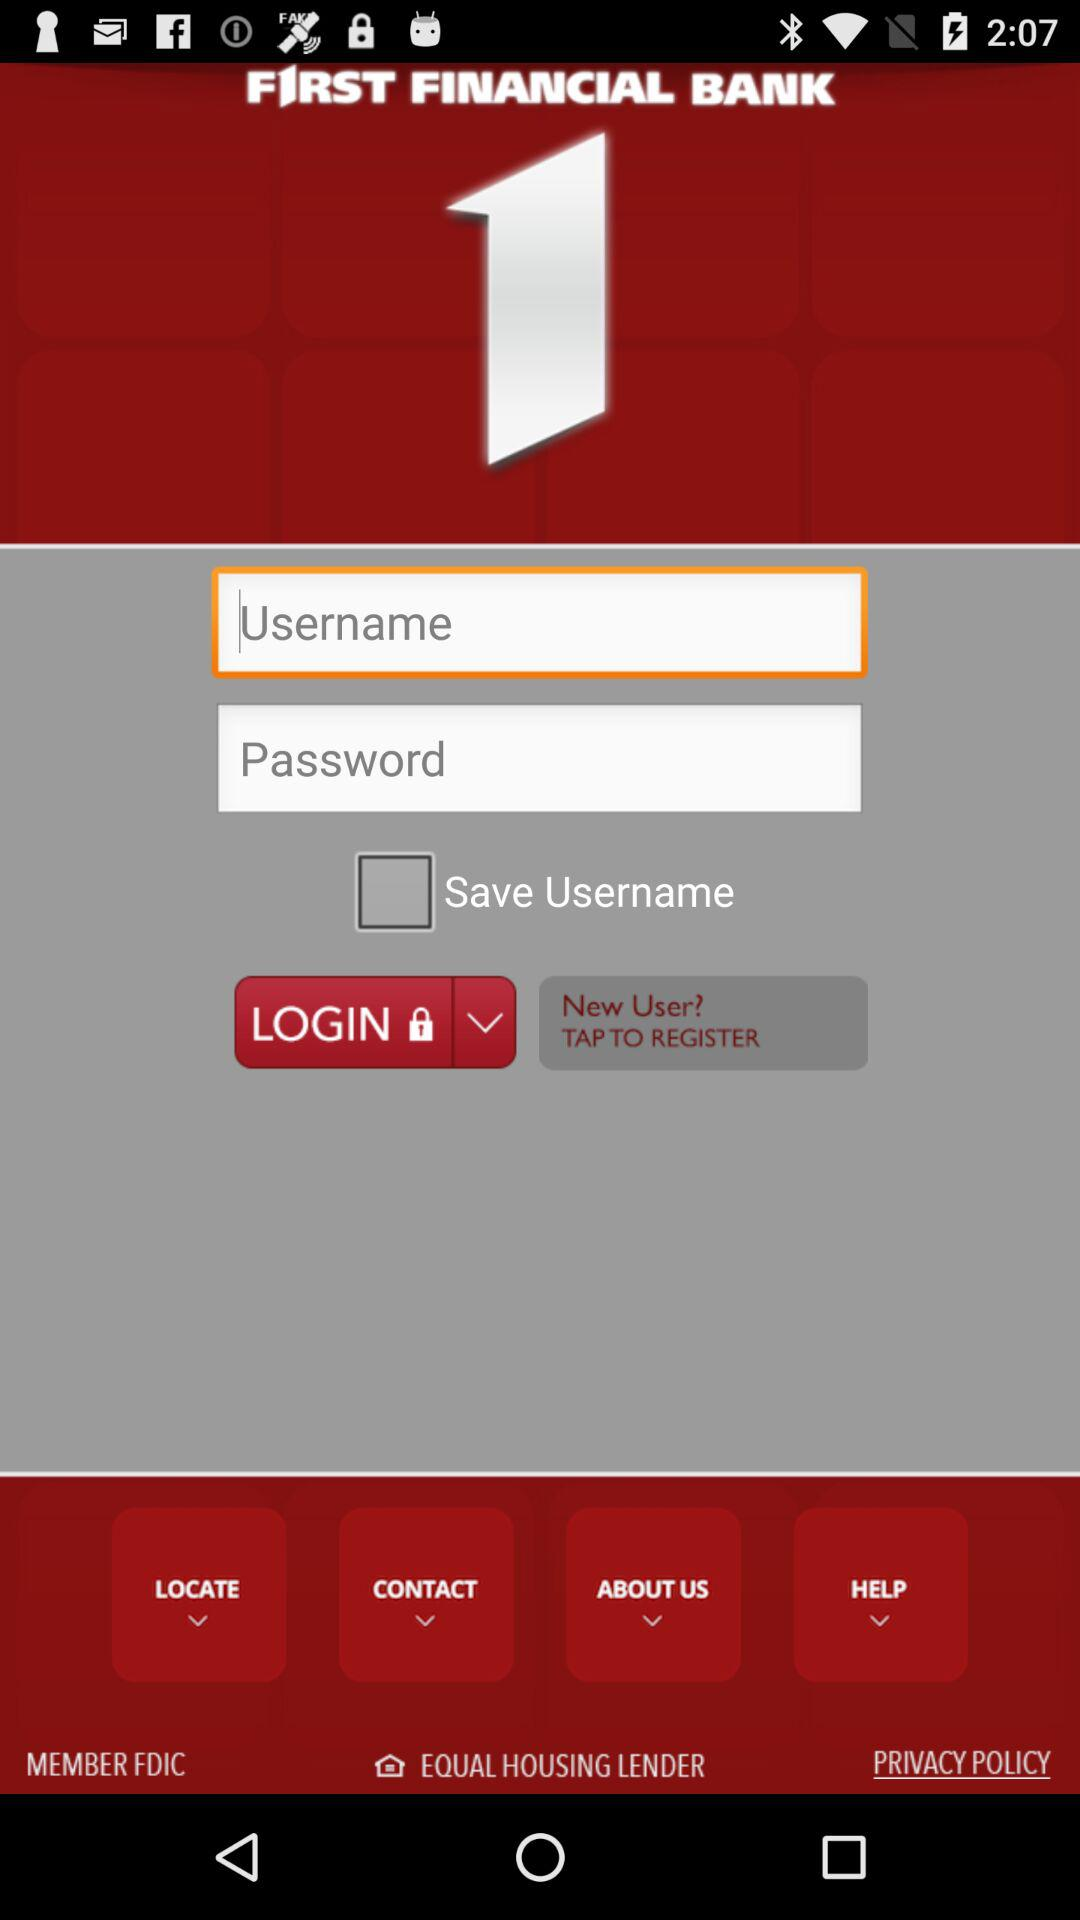What is the status of "Save Username"? The status is "off". 